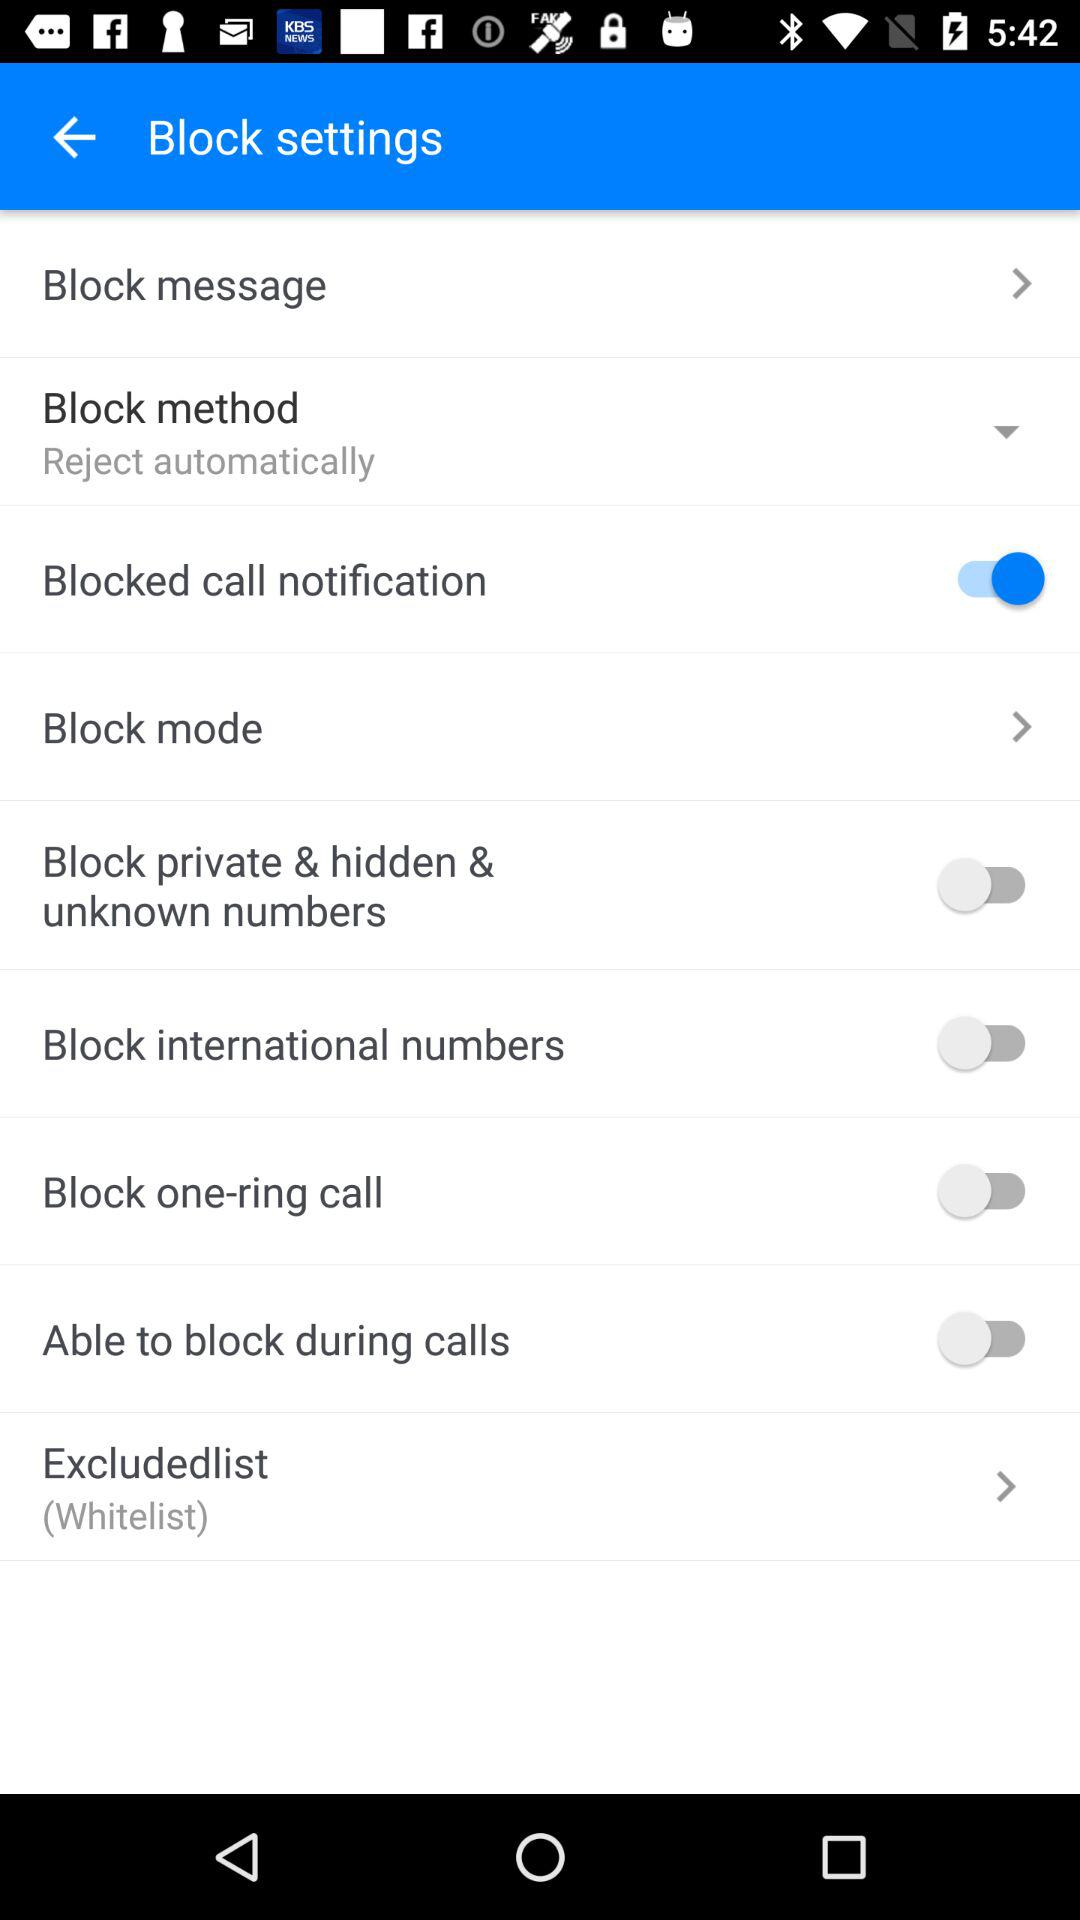How many items can be blocked in the block settings?
Answer the question using a single word or phrase. 8 